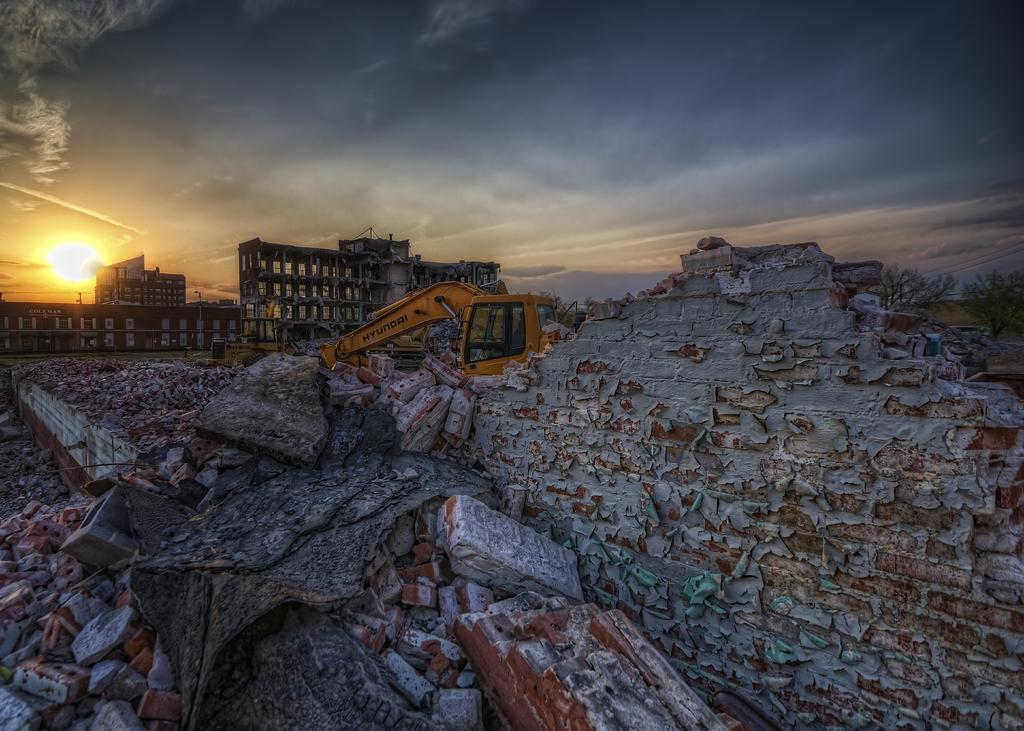What type of material is present in the image? There are bricks in the image. What structures can be seen in the image? There are buildings in the image. What type of vegetation is present in the image? There are trees in the image. What type of machinery is present in the image? There is a crane in the image. What type of damage can be seen in the image? There is a destructed wall in the image. What is visible in the background of the image? The sun and clouds in the sky are visible in the background of the image. What type of camp can be seen in the image? There is no camp present in the image. 